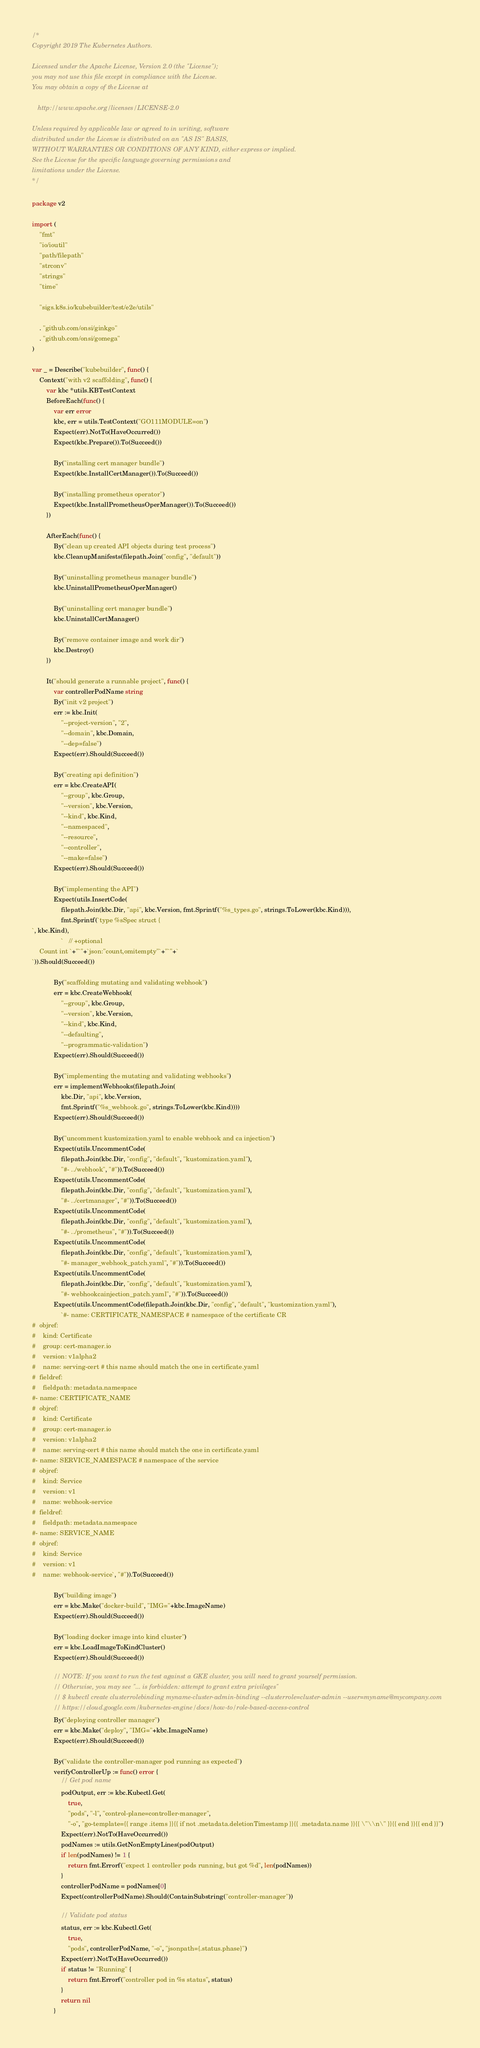<code> <loc_0><loc_0><loc_500><loc_500><_Go_>/*
Copyright 2019 The Kubernetes Authors.

Licensed under the Apache License, Version 2.0 (the "License");
you may not use this file except in compliance with the License.
You may obtain a copy of the License at

   http://www.apache.org/licenses/LICENSE-2.0

Unless required by applicable law or agreed to in writing, software
distributed under the License is distributed on an "AS IS" BASIS,
WITHOUT WARRANTIES OR CONDITIONS OF ANY KIND, either express or implied.
See the License for the specific language governing permissions and
limitations under the License.
*/

package v2

import (
	"fmt"
	"io/ioutil"
	"path/filepath"
	"strconv"
	"strings"
	"time"

	"sigs.k8s.io/kubebuilder/test/e2e/utils"

	. "github.com/onsi/ginkgo"
	. "github.com/onsi/gomega"
)

var _ = Describe("kubebuilder", func() {
	Context("with v2 scaffolding", func() {
		var kbc *utils.KBTestContext
		BeforeEach(func() {
			var err error
			kbc, err = utils.TestContext("GO111MODULE=on")
			Expect(err).NotTo(HaveOccurred())
			Expect(kbc.Prepare()).To(Succeed())

			By("installing cert manager bundle")
			Expect(kbc.InstallCertManager()).To(Succeed())

			By("installing prometheus operator")
			Expect(kbc.InstallPrometheusOperManager()).To(Succeed())
		})

		AfterEach(func() {
			By("clean up created API objects during test process")
			kbc.CleanupManifests(filepath.Join("config", "default"))

			By("uninstalling prometheus manager bundle")
			kbc.UninstallPrometheusOperManager()

			By("uninstalling cert manager bundle")
			kbc.UninstallCertManager()

			By("remove container image and work dir")
			kbc.Destroy()
		})

		It("should generate a runnable project", func() {
			var controllerPodName string
			By("init v2 project")
			err := kbc.Init(
				"--project-version", "2",
				"--domain", kbc.Domain,
				"--dep=false")
			Expect(err).Should(Succeed())

			By("creating api definition")
			err = kbc.CreateAPI(
				"--group", kbc.Group,
				"--version", kbc.Version,
				"--kind", kbc.Kind,
				"--namespaced",
				"--resource",
				"--controller",
				"--make=false")
			Expect(err).Should(Succeed())

			By("implementing the API")
			Expect(utils.InsertCode(
				filepath.Join(kbc.Dir, "api", kbc.Version, fmt.Sprintf("%s_types.go", strings.ToLower(kbc.Kind))),
				fmt.Sprintf(`type %sSpec struct {
`, kbc.Kind),
				`	// +optional
	Count int `+"`"+`json:"count,omitempty"`+"`"+`
`)).Should(Succeed())

			By("scaffolding mutating and validating webhook")
			err = kbc.CreateWebhook(
				"--group", kbc.Group,
				"--version", kbc.Version,
				"--kind", kbc.Kind,
				"--defaulting",
				"--programmatic-validation")
			Expect(err).Should(Succeed())

			By("implementing the mutating and validating webhooks")
			err = implementWebhooks(filepath.Join(
				kbc.Dir, "api", kbc.Version,
				fmt.Sprintf("%s_webhook.go", strings.ToLower(kbc.Kind))))
			Expect(err).Should(Succeed())

			By("uncomment kustomization.yaml to enable webhook and ca injection")
			Expect(utils.UncommentCode(
				filepath.Join(kbc.Dir, "config", "default", "kustomization.yaml"),
				"#- ../webhook", "#")).To(Succeed())
			Expect(utils.UncommentCode(
				filepath.Join(kbc.Dir, "config", "default", "kustomization.yaml"),
				"#- ../certmanager", "#")).To(Succeed())
			Expect(utils.UncommentCode(
				filepath.Join(kbc.Dir, "config", "default", "kustomization.yaml"),
				"#- ../prometheus", "#")).To(Succeed())
			Expect(utils.UncommentCode(
				filepath.Join(kbc.Dir, "config", "default", "kustomization.yaml"),
				"#- manager_webhook_patch.yaml", "#")).To(Succeed())
			Expect(utils.UncommentCode(
				filepath.Join(kbc.Dir, "config", "default", "kustomization.yaml"),
				"#- webhookcainjection_patch.yaml", "#")).To(Succeed())
			Expect(utils.UncommentCode(filepath.Join(kbc.Dir, "config", "default", "kustomization.yaml"),
				`#- name: CERTIFICATE_NAMESPACE # namespace of the certificate CR
#  objref:
#    kind: Certificate
#    group: cert-manager.io
#    version: v1alpha2
#    name: serving-cert # this name should match the one in certificate.yaml
#  fieldref:
#    fieldpath: metadata.namespace
#- name: CERTIFICATE_NAME
#  objref:
#    kind: Certificate
#    group: cert-manager.io
#    version: v1alpha2
#    name: serving-cert # this name should match the one in certificate.yaml
#- name: SERVICE_NAMESPACE # namespace of the service
#  objref:
#    kind: Service
#    version: v1
#    name: webhook-service
#  fieldref:
#    fieldpath: metadata.namespace
#- name: SERVICE_NAME
#  objref:
#    kind: Service
#    version: v1
#    name: webhook-service`, "#")).To(Succeed())

			By("building image")
			err = kbc.Make("docker-build", "IMG="+kbc.ImageName)
			Expect(err).Should(Succeed())

			By("loading docker image into kind cluster")
			err = kbc.LoadImageToKindCluster()
			Expect(err).Should(Succeed())

			// NOTE: If you want to run the test against a GKE cluster, you will need to grant yourself permission.
			// Otherwise, you may see "... is forbidden: attempt to grant extra privileges"
			// $ kubectl create clusterrolebinding myname-cluster-admin-binding --clusterrole=cluster-admin --user=myname@mycompany.com
			// https://cloud.google.com/kubernetes-engine/docs/how-to/role-based-access-control
			By("deploying controller manager")
			err = kbc.Make("deploy", "IMG="+kbc.ImageName)
			Expect(err).Should(Succeed())

			By("validate the controller-manager pod running as expected")
			verifyControllerUp := func() error {
				// Get pod name
				podOutput, err := kbc.Kubectl.Get(
					true,
					"pods", "-l", "control-plane=controller-manager",
					"-o", "go-template={{ range .items }}{{ if not .metadata.deletionTimestamp }}{{ .metadata.name }}{{ \"\\n\" }}{{ end }}{{ end }}")
				Expect(err).NotTo(HaveOccurred())
				podNames := utils.GetNonEmptyLines(podOutput)
				if len(podNames) != 1 {
					return fmt.Errorf("expect 1 controller pods running, but got %d", len(podNames))
				}
				controllerPodName = podNames[0]
				Expect(controllerPodName).Should(ContainSubstring("controller-manager"))

				// Validate pod status
				status, err := kbc.Kubectl.Get(
					true,
					"pods", controllerPodName, "-o", "jsonpath={.status.phase}")
				Expect(err).NotTo(HaveOccurred())
				if status != "Running" {
					return fmt.Errorf("controller pod in %s status", status)
				}
				return nil
			}</code> 